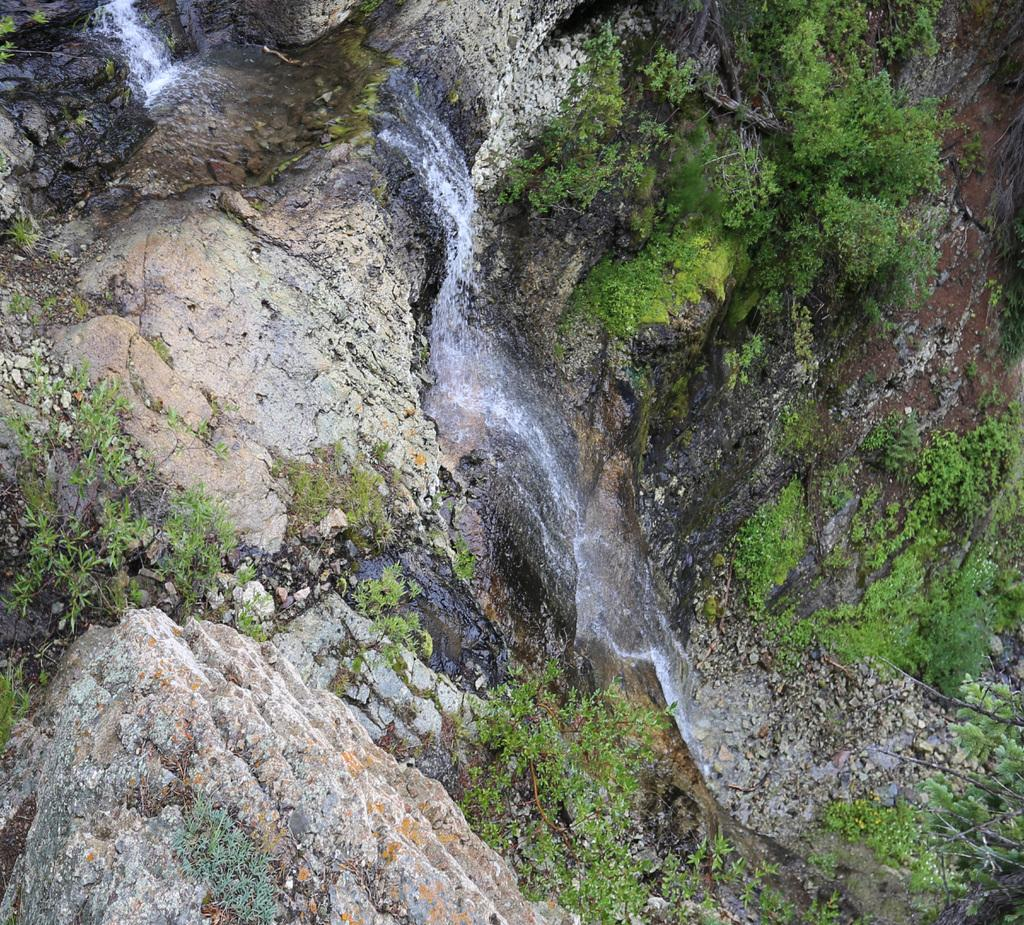What type of surface is visible in the image? There is a rock surface in the image. What colors can be seen on the rock surface? The rock surface is cream and brown in color. What type of vegetation is present in the image? There is grass and trees in the image. What is happening with the water in the image? Water is flowing through the rock surface. What is the impulse of the scene in the image? The image does not depict an impulse or any action taking place; it is a static scene. 